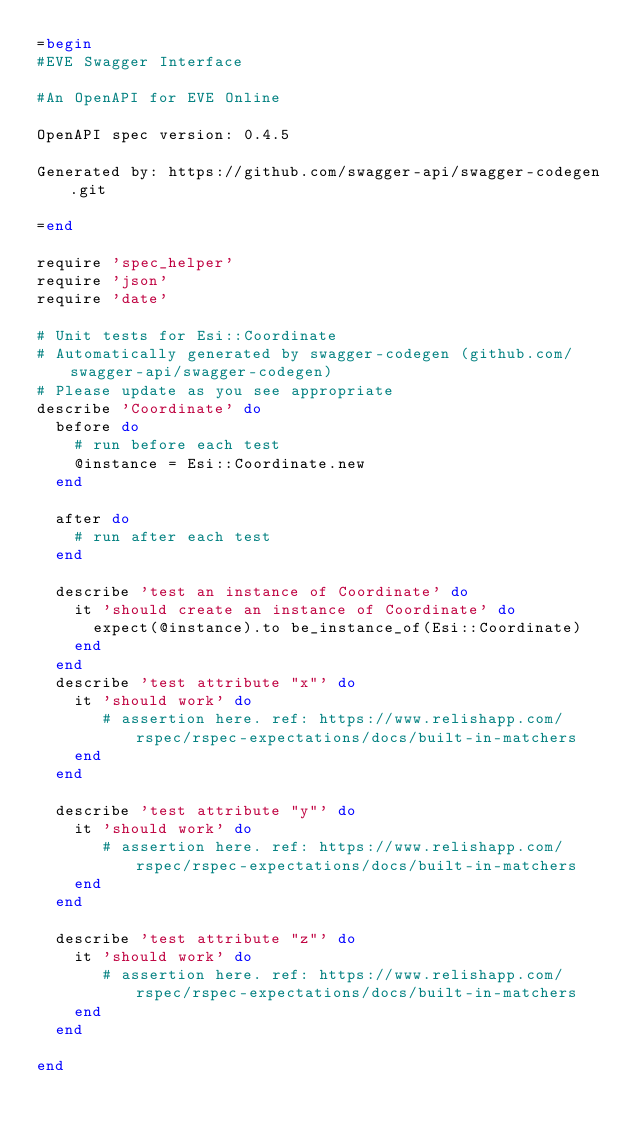<code> <loc_0><loc_0><loc_500><loc_500><_Ruby_>=begin
#EVE Swagger Interface

#An OpenAPI for EVE Online

OpenAPI spec version: 0.4.5

Generated by: https://github.com/swagger-api/swagger-codegen.git

=end

require 'spec_helper'
require 'json'
require 'date'

# Unit tests for Esi::Coordinate
# Automatically generated by swagger-codegen (github.com/swagger-api/swagger-codegen)
# Please update as you see appropriate
describe 'Coordinate' do
  before do
    # run before each test
    @instance = Esi::Coordinate.new
  end

  after do
    # run after each test
  end

  describe 'test an instance of Coordinate' do
    it 'should create an instance of Coordinate' do
      expect(@instance).to be_instance_of(Esi::Coordinate)
    end
  end
  describe 'test attribute "x"' do
    it 'should work' do
       # assertion here. ref: https://www.relishapp.com/rspec/rspec-expectations/docs/built-in-matchers
    end
  end

  describe 'test attribute "y"' do
    it 'should work' do
       # assertion here. ref: https://www.relishapp.com/rspec/rspec-expectations/docs/built-in-matchers
    end
  end

  describe 'test attribute "z"' do
    it 'should work' do
       # assertion here. ref: https://www.relishapp.com/rspec/rspec-expectations/docs/built-in-matchers
    end
  end

end

</code> 